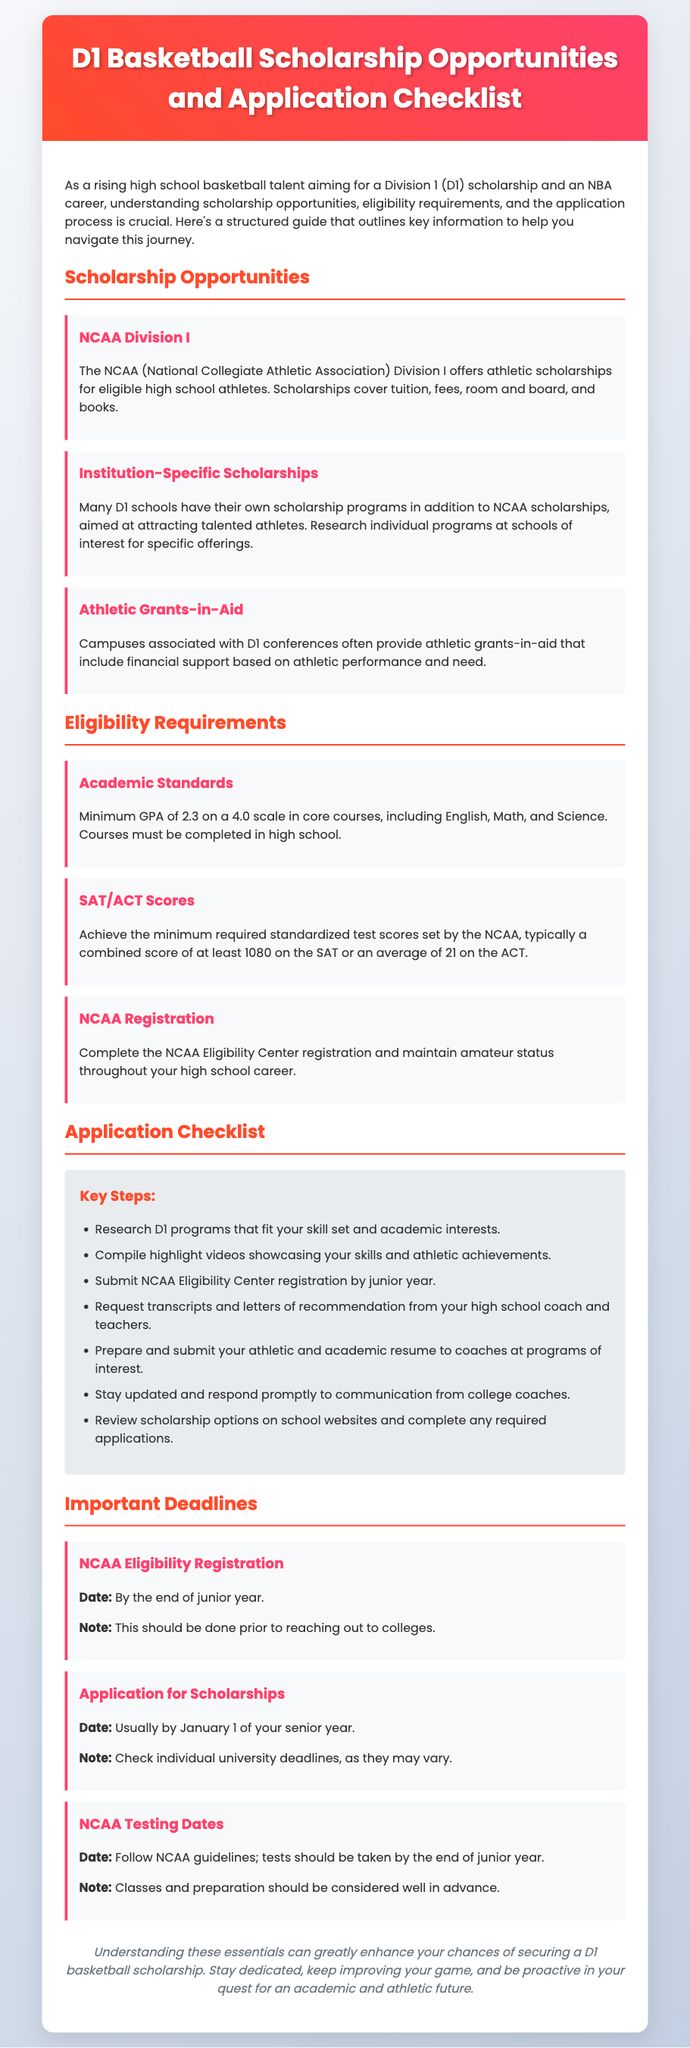What is the minimum GPA required for NCAA D1 eligibility? The document states that a minimum GPA of 2.3 on a 4.0 scale is required in core courses for NCAA D1 eligibility.
Answer: 2.3 What standardized test score is typically needed for NCAA D1 eligibility? The document specifies that a combined score of at least 1080 on the SAT or an average of 21 on the ACT is typical for NCAA D1 eligibility.
Answer: 1080 (SAT) When should you submit your NCAA Eligibility Center registration? According to the document, the NCAA Eligibility Center registration should be submitted by the end of junior year.
Answer: End of junior year Which organization offers athletic scholarships for D1 basketball? The document mentions that the NCAA (National Collegiate Athletic Association) Division I offers athletic scholarships for eligible high school athletes.
Answer: NCAA What is the deadline for applying for scholarships usually? The document indicates that the application for scholarships is usually due by January 1 of the senior year.
Answer: January 1 What should be included in the athletic and academic resume? The document suggests that the athletic and academic resume should highlight skills and achievements relevant to the desired D1 programs.
Answer: Skills and achievements What financial support do campuses associated with D1 conferences offer? The document states that campuses may provide athletic grants-in-aid that include financial support based on athletic performance and need.
Answer: Athletic grants-in-aid What should athletes do to stay updated with college coaches? The document advises athletes to stay updated and respond promptly to communication from college coaches.
Answer: Respond promptly What is one key step in the application checklist? The document lists compiling highlight videos showcasing skills and athletic achievements as a key step.
Answer: Compile highlight videos 